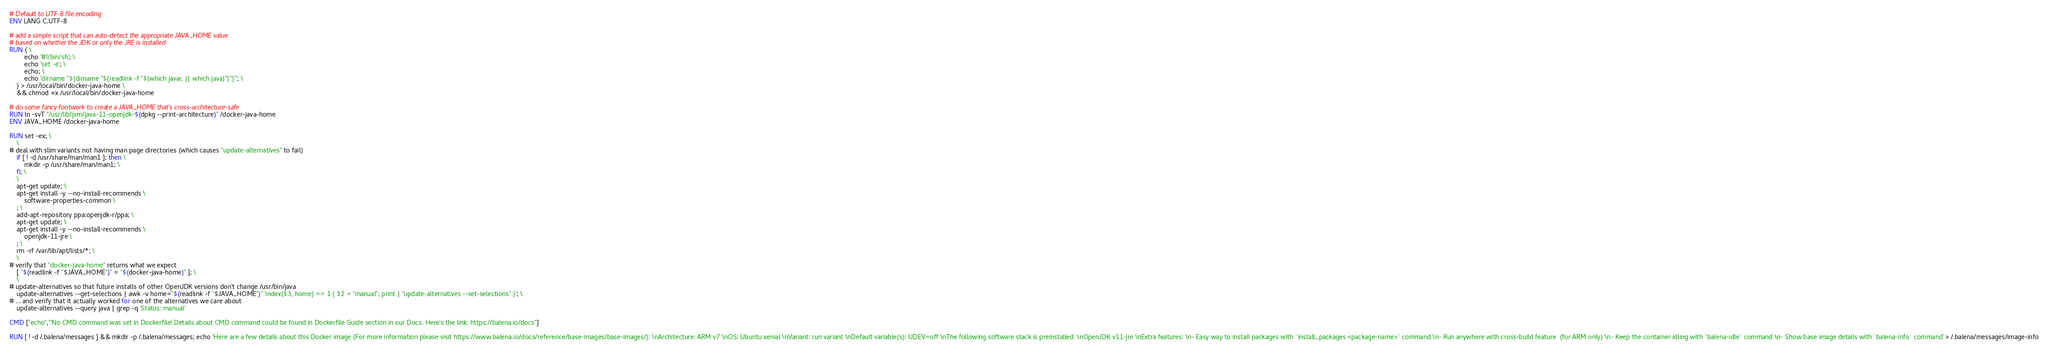Convert code to text. <code><loc_0><loc_0><loc_500><loc_500><_Dockerfile_># Default to UTF-8 file.encoding
ENV LANG C.UTF-8

# add a simple script that can auto-detect the appropriate JAVA_HOME value
# based on whether the JDK or only the JRE is installed
RUN { \
		echo '#!/bin/sh'; \
		echo 'set -e'; \
		echo; \
		echo 'dirname "$(dirname "$(readlink -f "$(which javac || which java)")")"'; \
	} > /usr/local/bin/docker-java-home \
	&& chmod +x /usr/local/bin/docker-java-home

# do some fancy footwork to create a JAVA_HOME that's cross-architecture-safe
RUN ln -svT "/usr/lib/jvm/java-11-openjdk-$(dpkg --print-architecture)" /docker-java-home
ENV JAVA_HOME /docker-java-home

RUN set -ex; \
	\
# deal with slim variants not having man page directories (which causes "update-alternatives" to fail)
	if [ ! -d /usr/share/man/man1 ]; then \
		mkdir -p /usr/share/man/man1; \
	fi; \
	\
	apt-get update; \
	apt-get install -y --no-install-recommends \
		software-properties-common \
	; \
	add-apt-repository ppa:openjdk-r/ppa; \
	apt-get update; \
	apt-get install -y --no-install-recommends \
		openjdk-11-jre \
	; \
	rm -rf /var/lib/apt/lists/*; \
	\
# verify that "docker-java-home" returns what we expect
	[ "$(readlink -f "$JAVA_HOME")" = "$(docker-java-home)" ]; \
	\
# update-alternatives so that future installs of other OpenJDK versions don't change /usr/bin/java
	update-alternatives --get-selections | awk -v home="$(readlink -f "$JAVA_HOME")" 'index($3, home) == 1 { $2 = "manual"; print | "update-alternatives --set-selections" }'; \
# ... and verify that it actually worked for one of the alternatives we care about
	update-alternatives --query java | grep -q 'Status: manual'

CMD ["echo","'No CMD command was set in Dockerfile! Details about CMD command could be found in Dockerfile Guide section in our Docs. Here's the link: https://balena.io/docs"]

RUN [ ! -d /.balena/messages ] && mkdir -p /.balena/messages; echo 'Here are a few details about this Docker image (For more information please visit https://www.balena.io/docs/reference/base-images/base-images/): \nArchitecture: ARM v7 \nOS: Ubuntu xenial \nVariant: run variant \nDefault variable(s): UDEV=off \nThe following software stack is preinstalled: \nOpenJDK v11-jre \nExtra features: \n- Easy way to install packages with `install_packages <package-name>` command \n- Run anywhere with cross-build feature  (for ARM only) \n- Keep the container idling with `balena-idle` command \n- Show base image details with `balena-info` command' > /.balena/messages/image-info</code> 